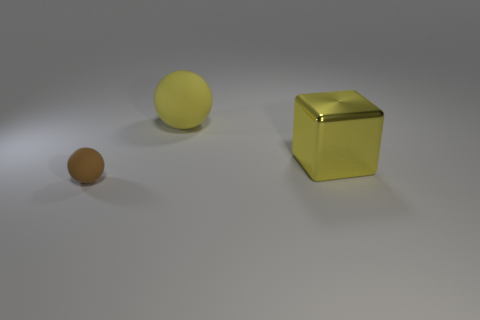Are there any other things that have the same shape as the shiny object?
Provide a succinct answer. No. Are there any other things that are the same size as the brown ball?
Give a very brief answer. No. What number of other objects are the same color as the big ball?
Your response must be concise. 1. There is a large object to the right of the big rubber ball to the right of the rubber thing that is in front of the large metal object; what color is it?
Provide a succinct answer. Yellow. Are there the same number of big things that are on the left side of the small brown matte sphere and purple objects?
Your answer should be compact. Yes. There is a matte thing to the right of the brown object; is it the same size as the brown thing?
Offer a terse response. No. How many tiny red shiny things are there?
Keep it short and to the point. 0. What number of balls are both in front of the big yellow metallic object and on the right side of the small sphere?
Your response must be concise. 0. Is there a yellow thing that has the same material as the small ball?
Keep it short and to the point. Yes. What is the material of the yellow cube that is behind the rubber sphere in front of the yellow ball?
Offer a terse response. Metal. 